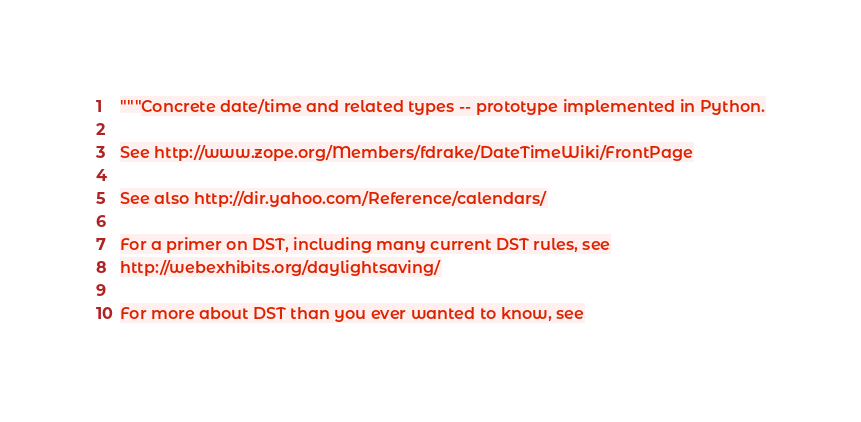<code> <loc_0><loc_0><loc_500><loc_500><_Python_>"""Concrete date/time and related types -- prototype implemented in Python.

See http://www.zope.org/Members/fdrake/DateTimeWiki/FrontPage

See also http://dir.yahoo.com/Reference/calendars/

For a primer on DST, including many current DST rules, see
http://webexhibits.org/daylightsaving/

For more about DST than you ever wanted to know, see</code> 